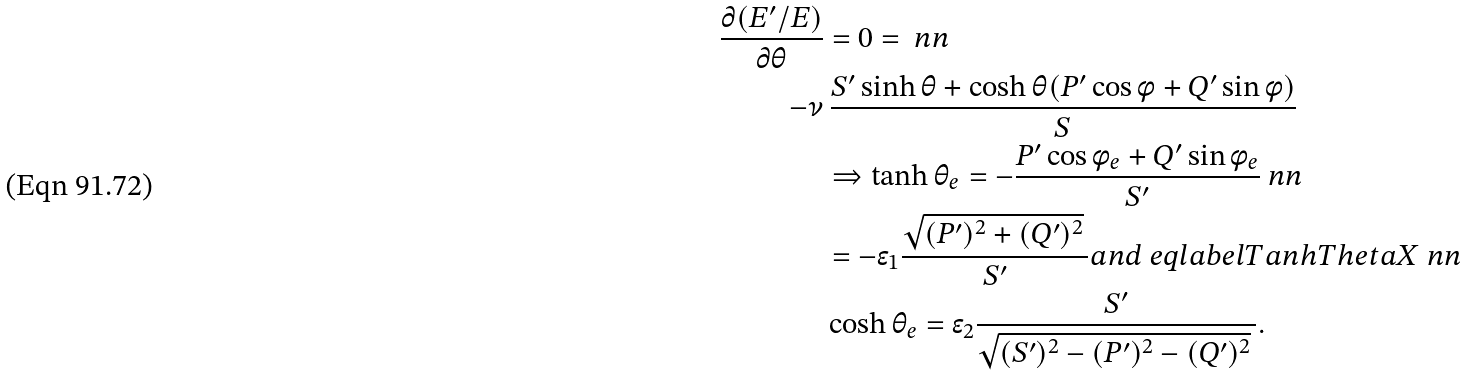<formula> <loc_0><loc_0><loc_500><loc_500>\frac { \partial ( E ^ { \prime } / E ) } { \partial \theta } & = 0 = \ n n \\ - \nu & \, \frac { S ^ { \prime } \sinh \theta + \cosh \theta ( P ^ { \prime } \cos \phi + Q ^ { \prime } \sin \phi ) } { S } \\ & \Rightarrow \tanh \theta _ { e } = - \frac { P ^ { \prime } \cos \phi _ { e } + Q ^ { \prime } \sin \phi _ { e } } { S ^ { \prime } } \ n n \\ & = - \epsilon _ { 1 } \frac { \sqrt { ( P ^ { \prime } ) ^ { 2 } + ( Q ^ { \prime } ) ^ { 2 } } \, } { S ^ { \prime } } a n d \ e q l a b e l { T a n h T h e t a X } \ n n \\ & \cosh \theta _ { e } = \epsilon _ { 2 } \frac { S ^ { \prime } } { \sqrt { ( S ^ { \prime } ) ^ { 2 } - ( P ^ { \prime } ) ^ { 2 } - ( Q ^ { \prime } ) ^ { 2 } } \, } .</formula> 